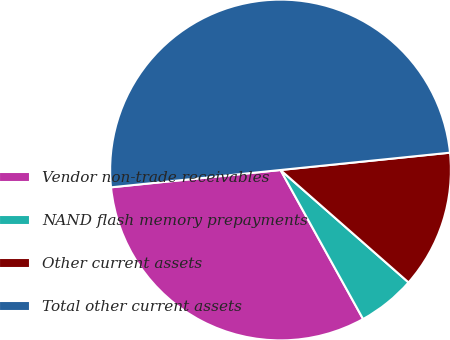<chart> <loc_0><loc_0><loc_500><loc_500><pie_chart><fcel>Vendor non-trade receivables<fcel>NAND flash memory prepayments<fcel>Other current assets<fcel>Total other current assets<nl><fcel>31.43%<fcel>5.48%<fcel>13.09%<fcel>50.0%<nl></chart> 